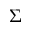Convert formula to latex. <formula><loc_0><loc_0><loc_500><loc_500>\Sigma</formula> 